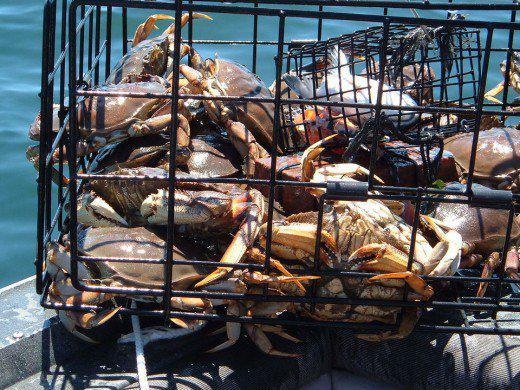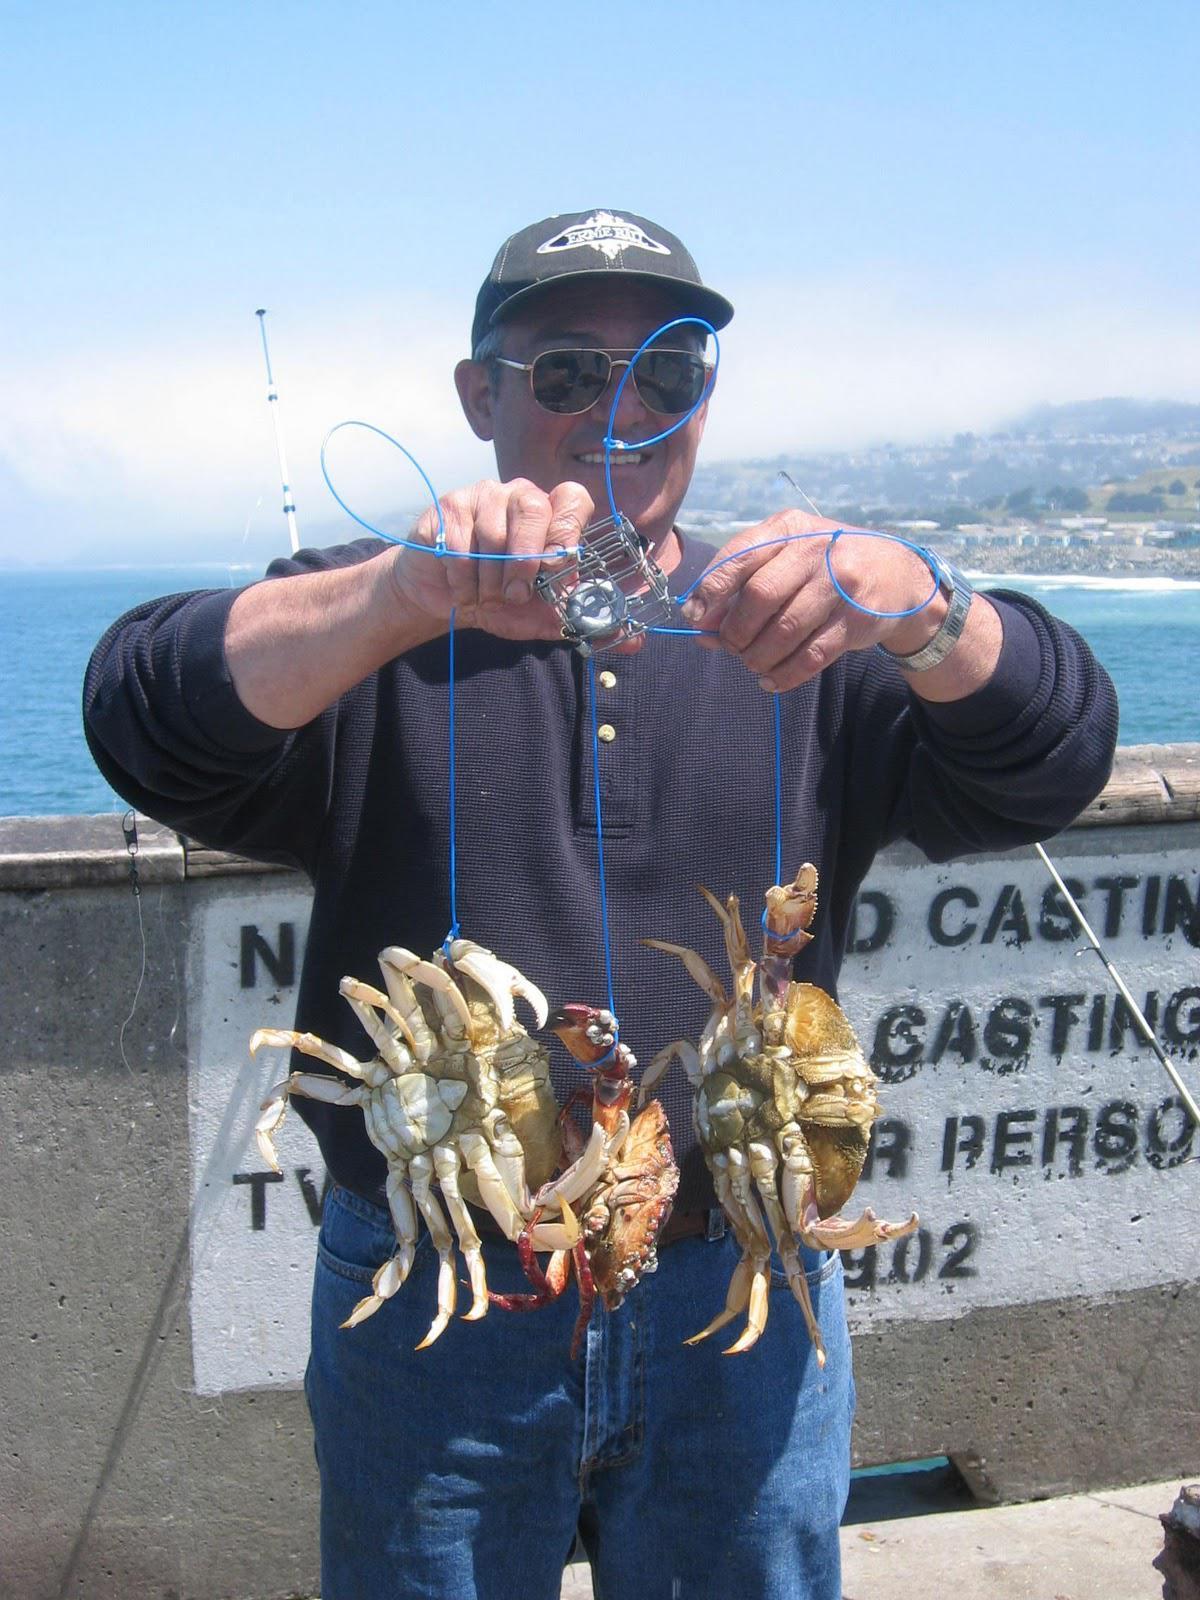The first image is the image on the left, the second image is the image on the right. Assess this claim about the two images: "A person is holding up a set of crabs in one of the images.". Correct or not? Answer yes or no. Yes. The first image is the image on the left, the second image is the image on the right. Assess this claim about the two images: "One image contains at least one human hand, and the other image includes some crabs and a box formed of a grid of box shapes.". Correct or not? Answer yes or no. Yes. 